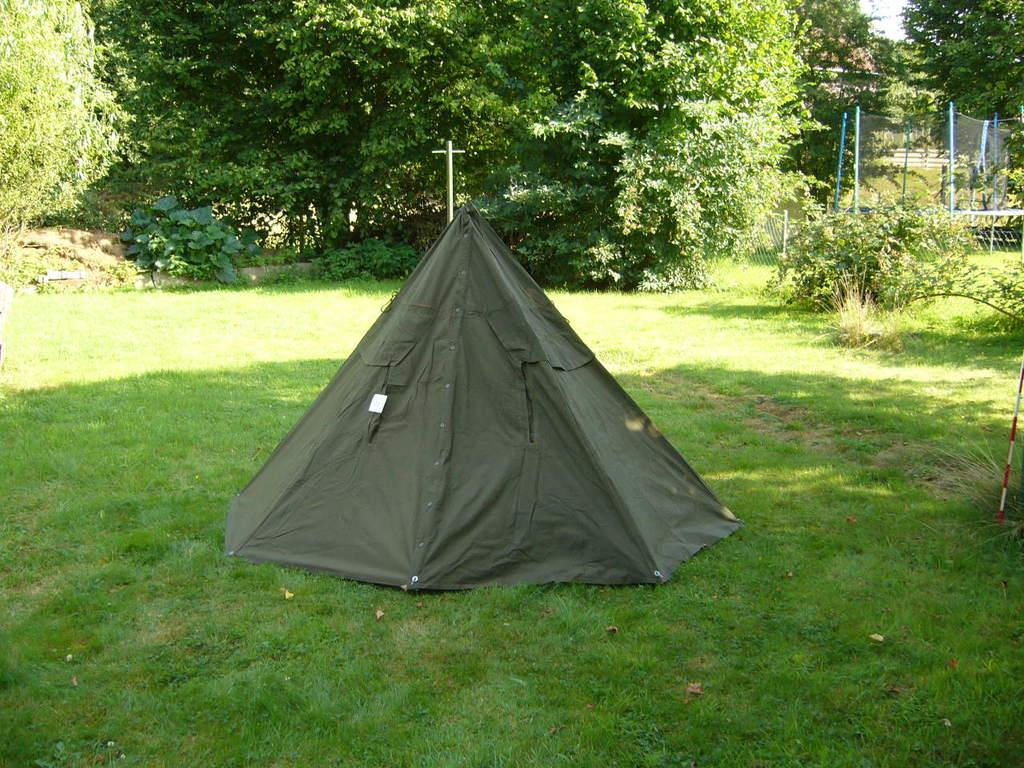What is the main subject of the image? There is a camp at the center of the image. What can be seen in the background of the image? There are trees and the sky visible in the background of the image. How many people are massing together at the camp in the image? There is no indication of people massing together in the image; it only shows a camp with trees and the sky in the background. 